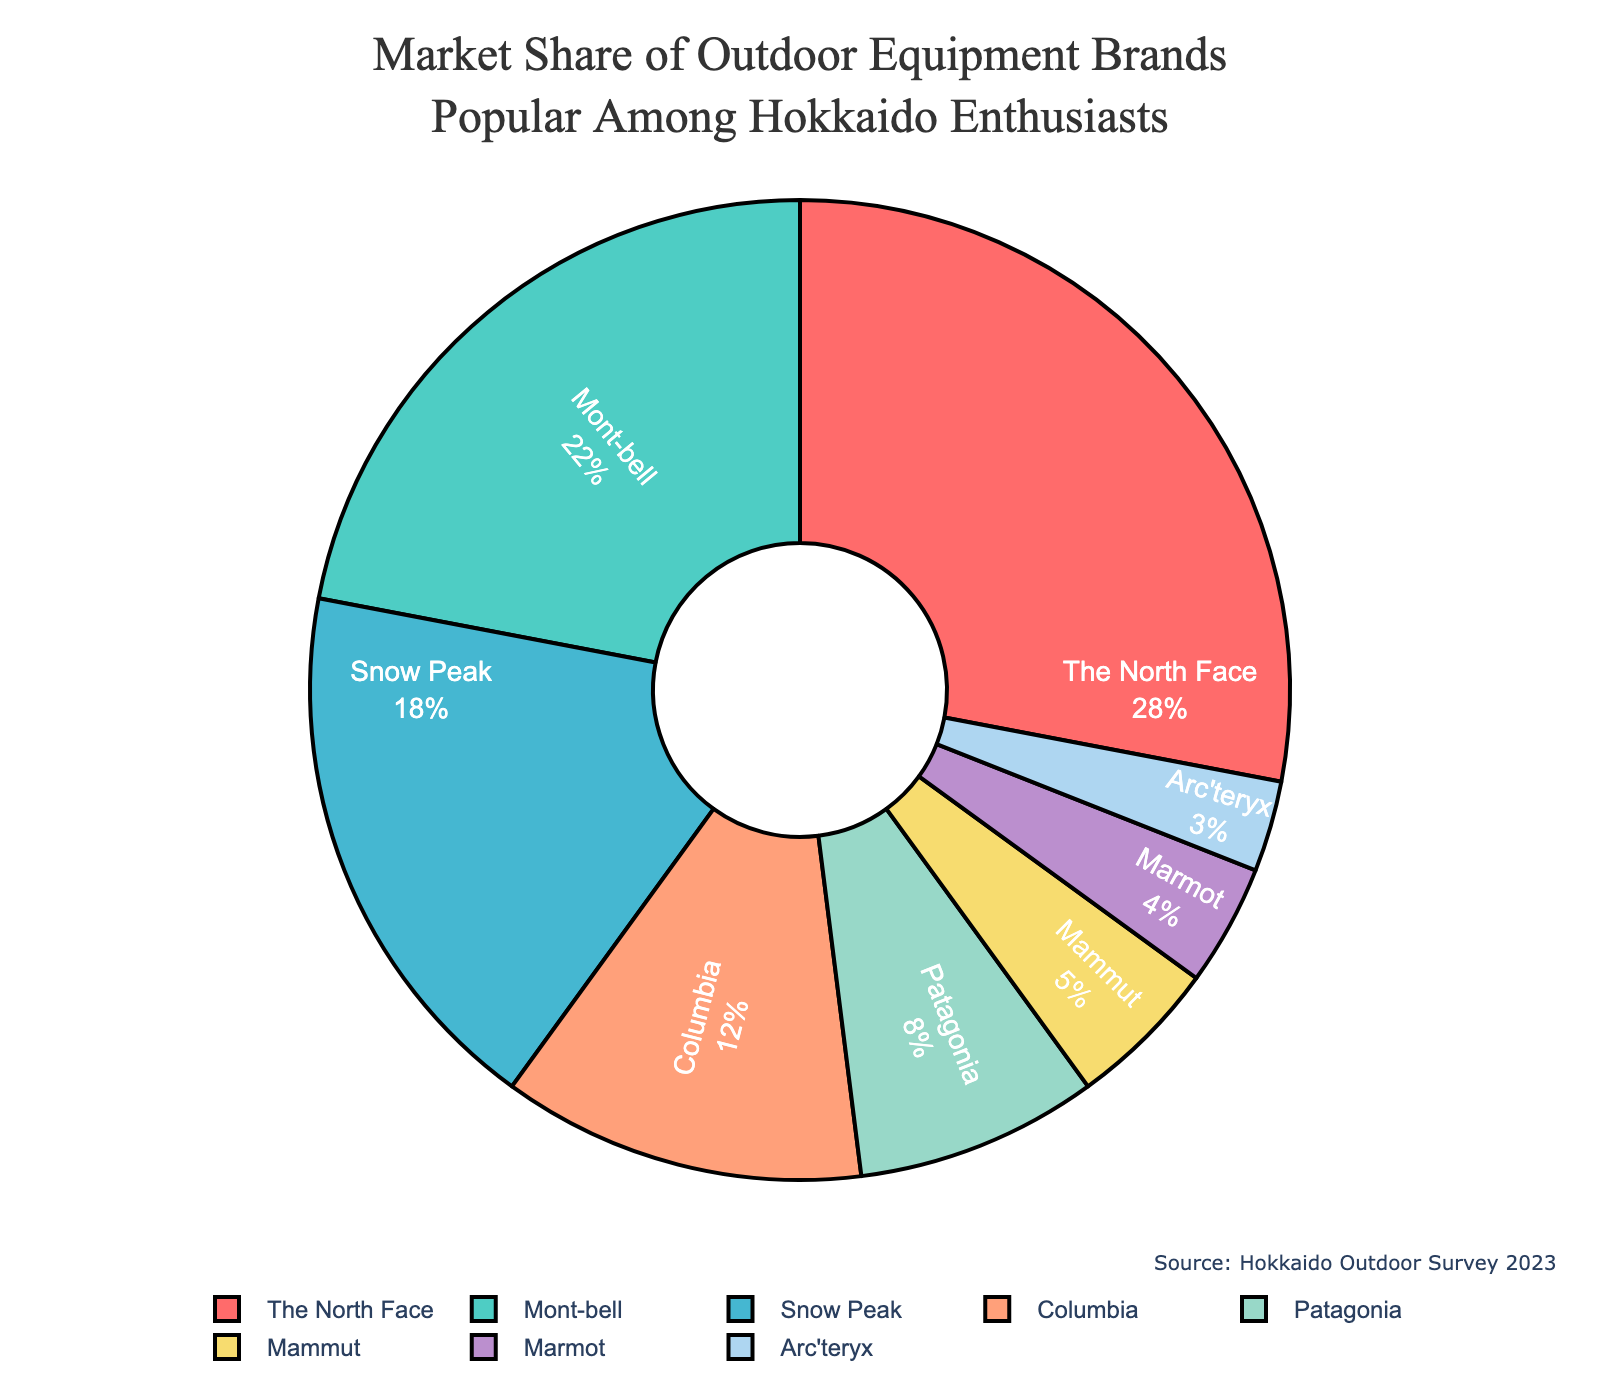What's the most popular outdoor equipment brand among Hokkaido enthusiasts? The pie chart shows the market share of different brands, with The North Face having the largest segment.
Answer: The North Face Which brand has the smallest market share? By looking at the smallest segment in the pie chart, Arc'teryx has the smallest share.
Answer: Arc'teryx What is the combined market share of Mont-bell and Snow Peak? Mont-bell has a market share of 22% and Snow Peak has 18%. Adding these together: 22 + 18 = 40.
Answer: 40% How much more market share does The North Face have compared to Columbia? The North Face has a market share of 28%, and Columbia has 12%. The difference is 28 - 12 = 16.
Answer: 16% Which brand has a market share closest to 10%? Among the brands listed, Patagonia has a market share of 8%, which is closest to 10%.
Answer: Patagonia What is the total market share of the three least popular brands? The three least popular brands are Mammut, Marmot, and Arc'teryx, with market shares of 5%, 4%, and 3%, respectively. Adding these together: 5 + 4 + 3 = 12.
Answer: 12% How does the market share of Snow Peak compare to that of Mont-bell? Snow Peak has an 18% market share, while Mont-bell has 22%. Thus, Snow Peak's share is 4% less than Mont-bell's.
Answer: 4% less What colors represent the market share segments for The North Face and Mont-bell? The pie chart uses a custom color palette where The North Face is shown in red and Mont-bell in turquoise.
Answer: The North Face: red, Mont-bell: turquoise What percentage of the market is held by brands other than the top three? The top three brands (The North Face, Mont-bell, Snow Peak) have market shares of 28%, 22%, and 18%, respectively. Adding these, 28 + 22 + 18 = 68%. The rest of the market is 100 - 68 = 32%.
Answer: 32% How does the combined market share of Columbia and Patagonia compare to that of Mammut and Marmot? Columbia and Patagonia have a combined market share of 12 + 8 = 20%. Mammut and Marmot together have 5 + 4 = 9%. 20% is 11% more than 9%.
Answer: 11% more 